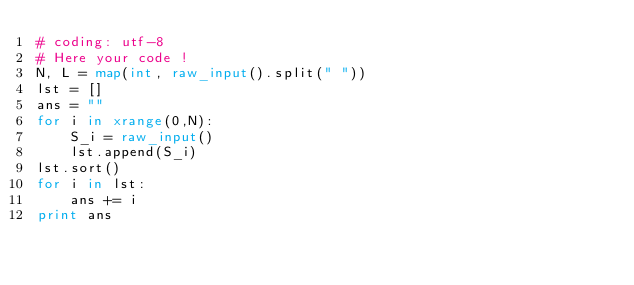<code> <loc_0><loc_0><loc_500><loc_500><_Python_># coding: utf-8
# Here your code !
N, L = map(int, raw_input().split(" "))
lst = []
ans = ""
for i in xrange(0,N):
    S_i = raw_input()
    lst.append(S_i)
lst.sort()
for i in lst:
    ans += i
print ans</code> 